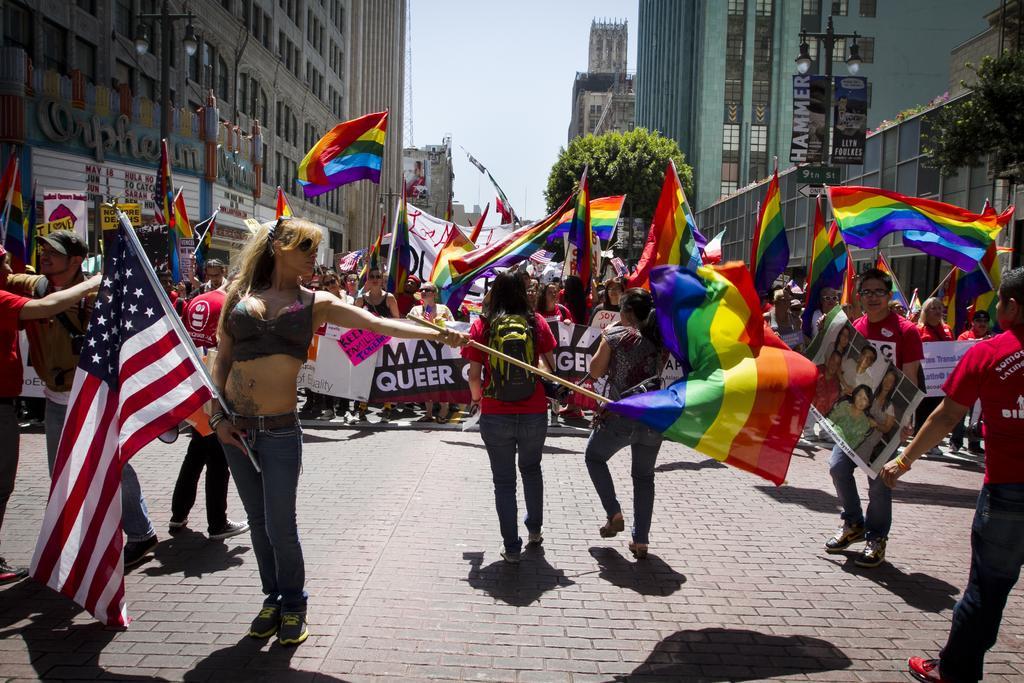In one or two sentences, can you explain what this image depicts? In this image, we can see some people standing and they are holding some flags and posters, there are some buildings and there is a green tree, at the top there is a sky. 